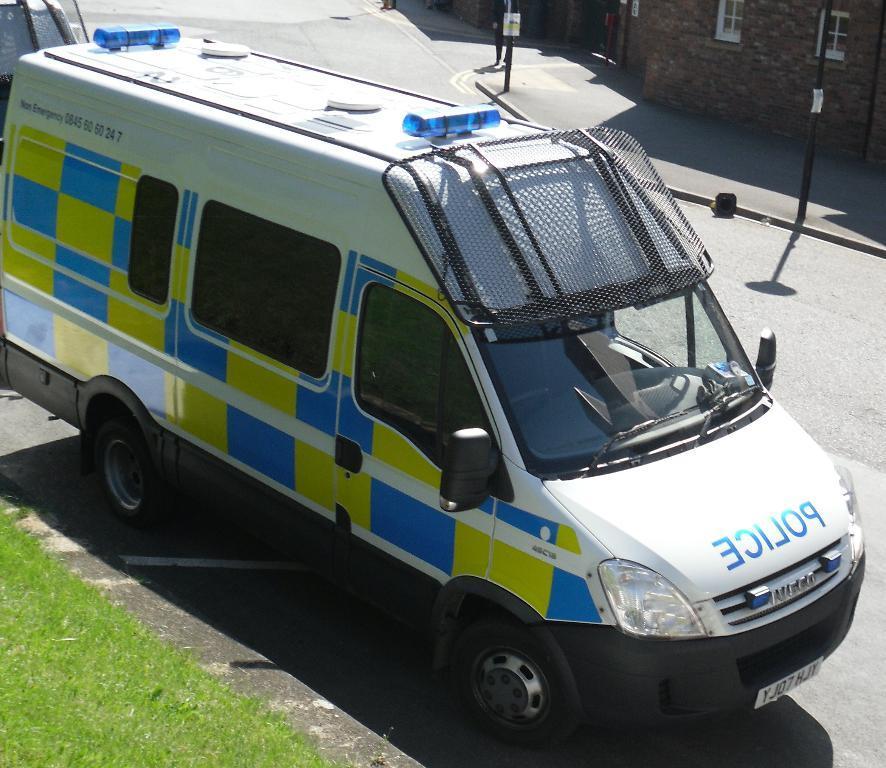In one or two sentences, can you explain what this image depicts? There is a vehicle with windows, lights and something written on that. On the left corner there is grass lawn. On the right corner there are poles and building with windows. 